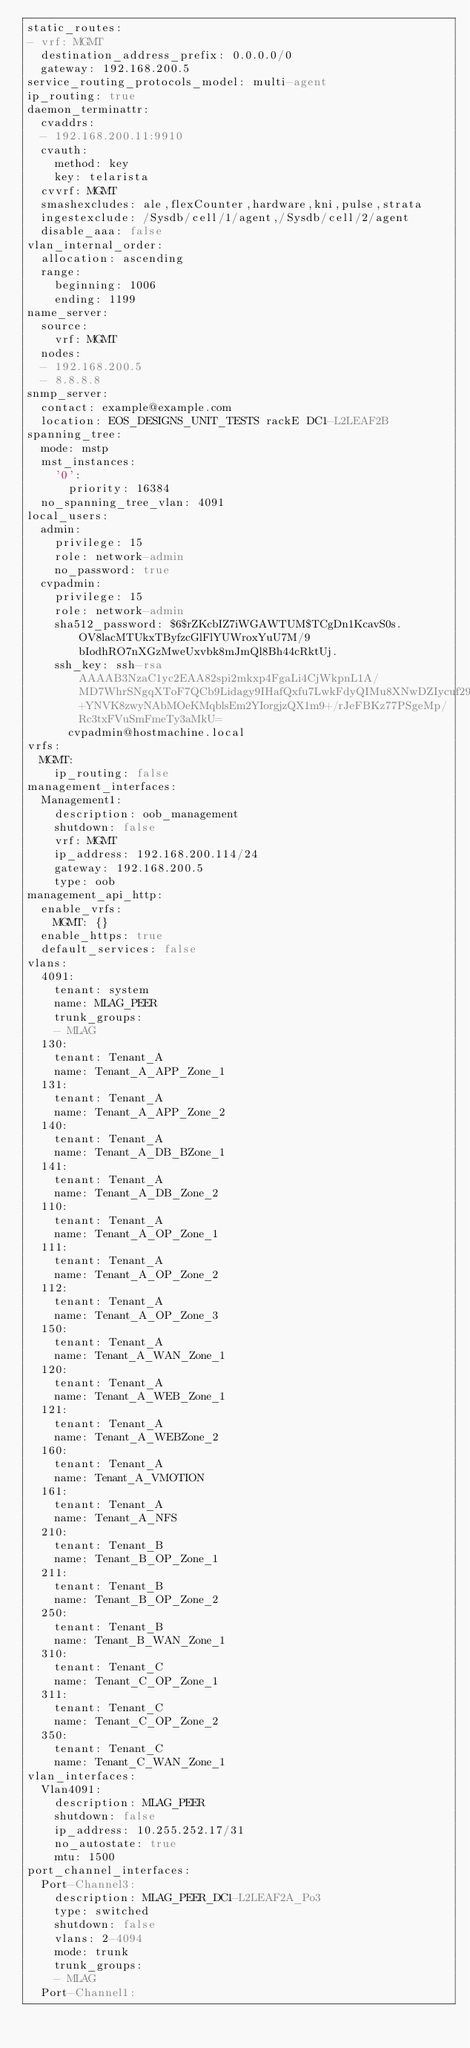Convert code to text. <code><loc_0><loc_0><loc_500><loc_500><_YAML_>static_routes:
- vrf: MGMT
  destination_address_prefix: 0.0.0.0/0
  gateway: 192.168.200.5
service_routing_protocols_model: multi-agent
ip_routing: true
daemon_terminattr:
  cvaddrs:
  - 192.168.200.11:9910
  cvauth:
    method: key
    key: telarista
  cvvrf: MGMT
  smashexcludes: ale,flexCounter,hardware,kni,pulse,strata
  ingestexclude: /Sysdb/cell/1/agent,/Sysdb/cell/2/agent
  disable_aaa: false
vlan_internal_order:
  allocation: ascending
  range:
    beginning: 1006
    ending: 1199
name_server:
  source:
    vrf: MGMT
  nodes:
  - 192.168.200.5
  - 8.8.8.8
snmp_server:
  contact: example@example.com
  location: EOS_DESIGNS_UNIT_TESTS rackE DC1-L2LEAF2B
spanning_tree:
  mode: mstp
  mst_instances:
    '0':
      priority: 16384
  no_spanning_tree_vlan: 4091
local_users:
  admin:
    privilege: 15
    role: network-admin
    no_password: true
  cvpadmin:
    privilege: 15
    role: network-admin
    sha512_password: $6$rZKcbIZ7iWGAWTUM$TCgDn1KcavS0s.OV8lacMTUkxTByfzcGlFlYUWroxYuU7M/9bIodhRO7nXGzMweUxvbk8mJmQl8Bh44cRktUj.
    ssh_key: ssh-rsa AAAAB3NzaC1yc2EAA82spi2mkxp4FgaLi4CjWkpnL1A/MD7WhrSNgqXToF7QCb9Lidagy9IHafQxfu7LwkFdyQIMu8XNwDZIycuf29wHbDdz1N+YNVK8zwyNAbMOeKMqblsEm2YIorgjzQX1m9+/rJeFBKz77PSgeMp/Rc3txFVuSmFmeTy3aMkU=
      cvpadmin@hostmachine.local
vrfs:
  MGMT:
    ip_routing: false
management_interfaces:
  Management1:
    description: oob_management
    shutdown: false
    vrf: MGMT
    ip_address: 192.168.200.114/24
    gateway: 192.168.200.5
    type: oob
management_api_http:
  enable_vrfs:
    MGMT: {}
  enable_https: true
  default_services: false
vlans:
  4091:
    tenant: system
    name: MLAG_PEER
    trunk_groups:
    - MLAG
  130:
    tenant: Tenant_A
    name: Tenant_A_APP_Zone_1
  131:
    tenant: Tenant_A
    name: Tenant_A_APP_Zone_2
  140:
    tenant: Tenant_A
    name: Tenant_A_DB_BZone_1
  141:
    tenant: Tenant_A
    name: Tenant_A_DB_Zone_2
  110:
    tenant: Tenant_A
    name: Tenant_A_OP_Zone_1
  111:
    tenant: Tenant_A
    name: Tenant_A_OP_Zone_2
  112:
    tenant: Tenant_A
    name: Tenant_A_OP_Zone_3
  150:
    tenant: Tenant_A
    name: Tenant_A_WAN_Zone_1
  120:
    tenant: Tenant_A
    name: Tenant_A_WEB_Zone_1
  121:
    tenant: Tenant_A
    name: Tenant_A_WEBZone_2
  160:
    tenant: Tenant_A
    name: Tenant_A_VMOTION
  161:
    tenant: Tenant_A
    name: Tenant_A_NFS
  210:
    tenant: Tenant_B
    name: Tenant_B_OP_Zone_1
  211:
    tenant: Tenant_B
    name: Tenant_B_OP_Zone_2
  250:
    tenant: Tenant_B
    name: Tenant_B_WAN_Zone_1
  310:
    tenant: Tenant_C
    name: Tenant_C_OP_Zone_1
  311:
    tenant: Tenant_C
    name: Tenant_C_OP_Zone_2
  350:
    tenant: Tenant_C
    name: Tenant_C_WAN_Zone_1
vlan_interfaces:
  Vlan4091:
    description: MLAG_PEER
    shutdown: false
    ip_address: 10.255.252.17/31
    no_autostate: true
    mtu: 1500
port_channel_interfaces:
  Port-Channel3:
    description: MLAG_PEER_DC1-L2LEAF2A_Po3
    type: switched
    shutdown: false
    vlans: 2-4094
    mode: trunk
    trunk_groups:
    - MLAG
  Port-Channel1:</code> 